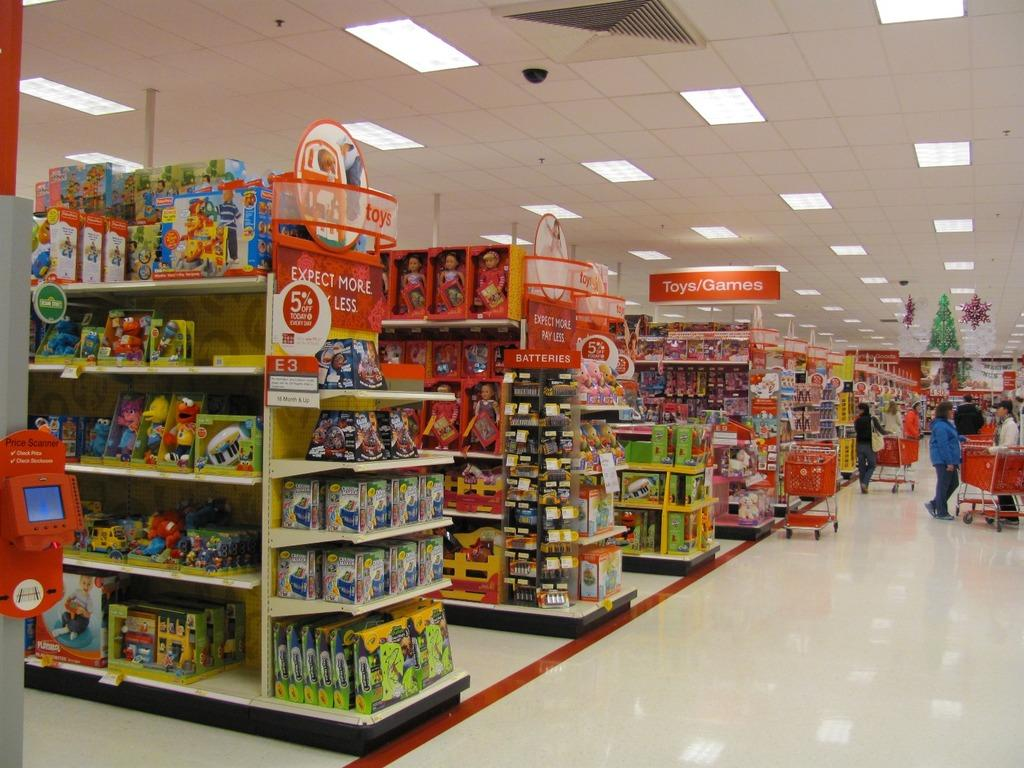Provide a one-sentence caption for the provided image. A large store in which the toys and games section is up ahead on the left. 